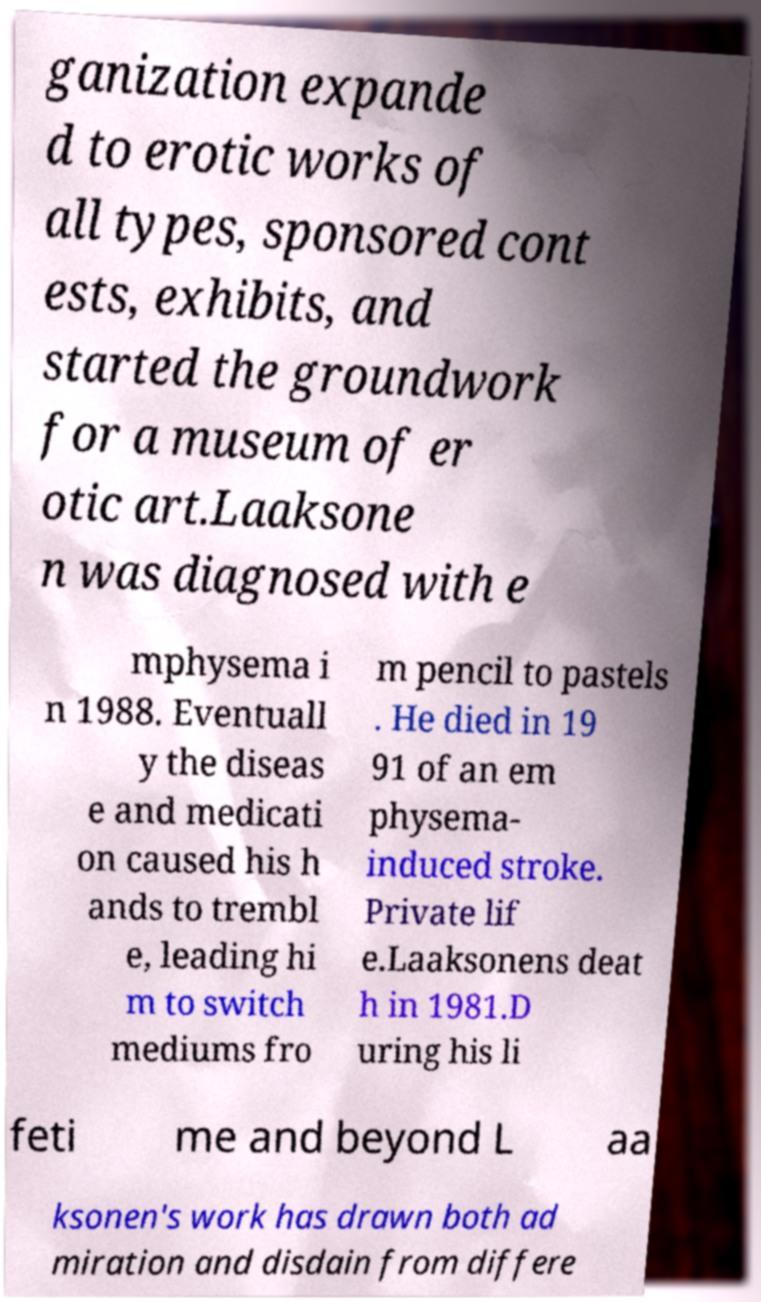I need the written content from this picture converted into text. Can you do that? ganization expande d to erotic works of all types, sponsored cont ests, exhibits, and started the groundwork for a museum of er otic art.Laaksone n was diagnosed with e mphysema i n 1988. Eventuall y the diseas e and medicati on caused his h ands to trembl e, leading hi m to switch mediums fro m pencil to pastels . He died in 19 91 of an em physema- induced stroke. Private lif e.Laaksonens deat h in 1981.D uring his li feti me and beyond L aa ksonen's work has drawn both ad miration and disdain from differe 